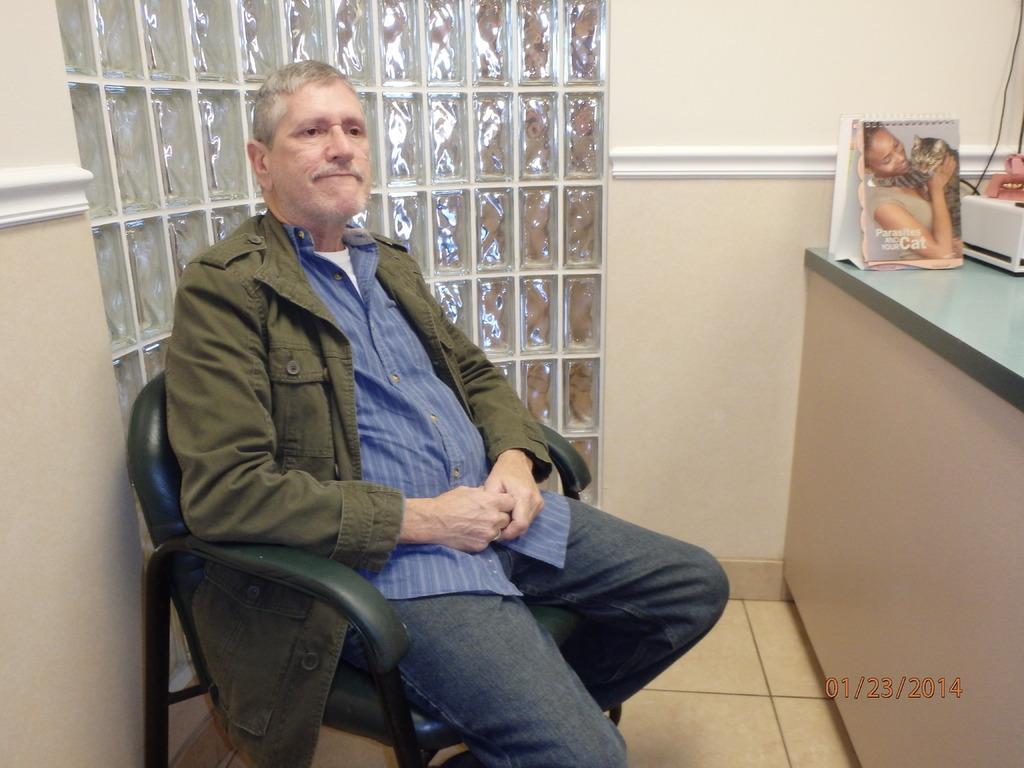In one or two sentences, can you explain what this image depicts? In this image we can see a person sitting on the chair. We can see few object at the right side of the image. 